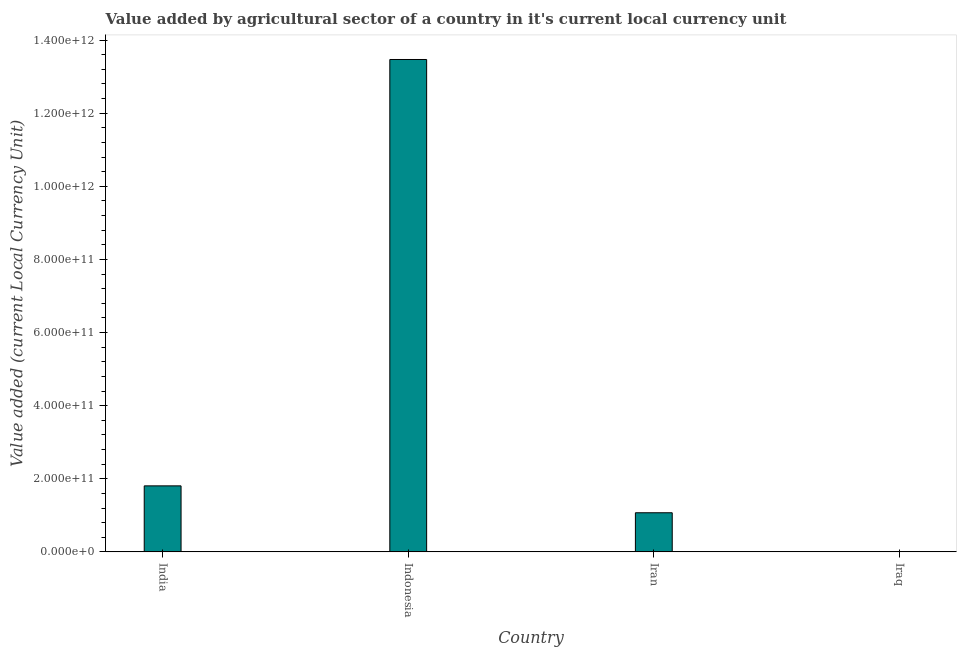What is the title of the graph?
Your answer should be very brief. Value added by agricultural sector of a country in it's current local currency unit. What is the label or title of the X-axis?
Your answer should be compact. Country. What is the label or title of the Y-axis?
Your answer should be compact. Value added (current Local Currency Unit). What is the value added by agriculture sector in India?
Make the answer very short. 1.81e+11. Across all countries, what is the maximum value added by agriculture sector?
Make the answer very short. 1.35e+12. Across all countries, what is the minimum value added by agriculture sector?
Keep it short and to the point. 1.61e+08. In which country was the value added by agriculture sector maximum?
Make the answer very short. Indonesia. In which country was the value added by agriculture sector minimum?
Offer a very short reply. Iraq. What is the sum of the value added by agriculture sector?
Your answer should be very brief. 1.63e+12. What is the difference between the value added by agriculture sector in India and Iran?
Give a very brief answer. 7.36e+1. What is the average value added by agriculture sector per country?
Provide a succinct answer. 4.09e+11. What is the median value added by agriculture sector?
Your response must be concise. 1.44e+11. What is the ratio of the value added by agriculture sector in India to that in Iraq?
Your answer should be very brief. 1118.92. Is the difference between the value added by agriculture sector in India and Iraq greater than the difference between any two countries?
Your answer should be very brief. No. What is the difference between the highest and the second highest value added by agriculture sector?
Offer a terse response. 1.17e+12. Is the sum of the value added by agriculture sector in Indonesia and Iraq greater than the maximum value added by agriculture sector across all countries?
Offer a terse response. Yes. What is the difference between the highest and the lowest value added by agriculture sector?
Provide a short and direct response. 1.35e+12. How many countries are there in the graph?
Ensure brevity in your answer.  4. What is the difference between two consecutive major ticks on the Y-axis?
Keep it short and to the point. 2.00e+11. Are the values on the major ticks of Y-axis written in scientific E-notation?
Provide a succinct answer. Yes. What is the Value added (current Local Currency Unit) of India?
Offer a terse response. 1.81e+11. What is the Value added (current Local Currency Unit) of Indonesia?
Offer a very short reply. 1.35e+12. What is the Value added (current Local Currency Unit) in Iran?
Make the answer very short. 1.07e+11. What is the Value added (current Local Currency Unit) in Iraq?
Your answer should be very brief. 1.61e+08. What is the difference between the Value added (current Local Currency Unit) in India and Indonesia?
Your answer should be compact. -1.17e+12. What is the difference between the Value added (current Local Currency Unit) in India and Iran?
Offer a terse response. 7.36e+1. What is the difference between the Value added (current Local Currency Unit) in India and Iraq?
Your response must be concise. 1.80e+11. What is the difference between the Value added (current Local Currency Unit) in Indonesia and Iran?
Your answer should be compact. 1.24e+12. What is the difference between the Value added (current Local Currency Unit) in Indonesia and Iraq?
Make the answer very short. 1.35e+12. What is the difference between the Value added (current Local Currency Unit) in Iran and Iraq?
Provide a short and direct response. 1.07e+11. What is the ratio of the Value added (current Local Currency Unit) in India to that in Indonesia?
Keep it short and to the point. 0.13. What is the ratio of the Value added (current Local Currency Unit) in India to that in Iran?
Keep it short and to the point. 1.69. What is the ratio of the Value added (current Local Currency Unit) in India to that in Iraq?
Your answer should be compact. 1118.92. What is the ratio of the Value added (current Local Currency Unit) in Indonesia to that in Iran?
Keep it short and to the point. 12.59. What is the ratio of the Value added (current Local Currency Unit) in Indonesia to that in Iraq?
Give a very brief answer. 8345.91. What is the ratio of the Value added (current Local Currency Unit) in Iran to that in Iraq?
Your answer should be very brief. 662.93. 